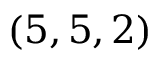Convert formula to latex. <formula><loc_0><loc_0><loc_500><loc_500>( 5 , 5 , 2 )</formula> 